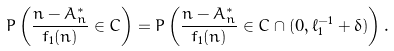<formula> <loc_0><loc_0><loc_500><loc_500>P \left ( \frac { n - A _ { n } ^ { * } } { f _ { 1 } ( n ) } \in C \right ) = P \left ( \frac { n - A _ { n } ^ { * } } { f _ { 1 } ( n ) } \in C \cap ( 0 , \ell _ { 1 } ^ { - 1 } + \delta ) \right ) .</formula> 